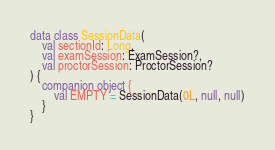<code> <loc_0><loc_0><loc_500><loc_500><_Kotlin_>data class SessionData(
    val sectionId: Long,
    val examSession: ExamSession?,
    val proctorSession: ProctorSession?
) {
    companion object {
        val EMPTY = SessionData(0L, null, null)
    }
}
</code> 